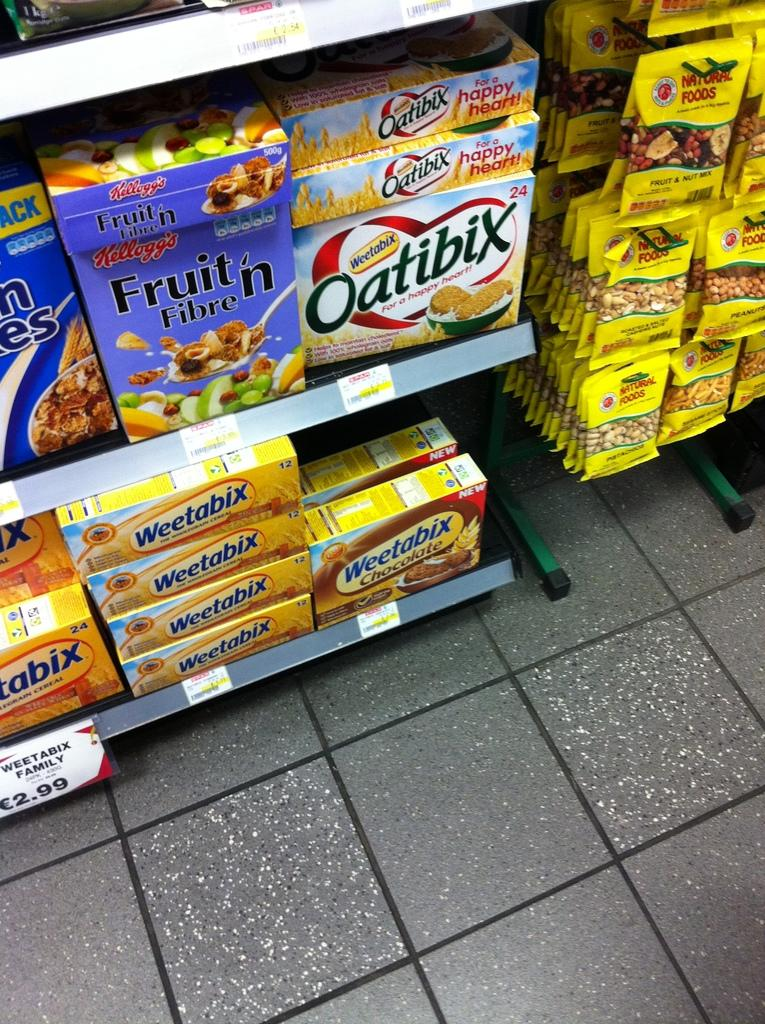<image>
Offer a succinct explanation of the picture presented. A convenience store with a cereal aisle that has Oatibix. 